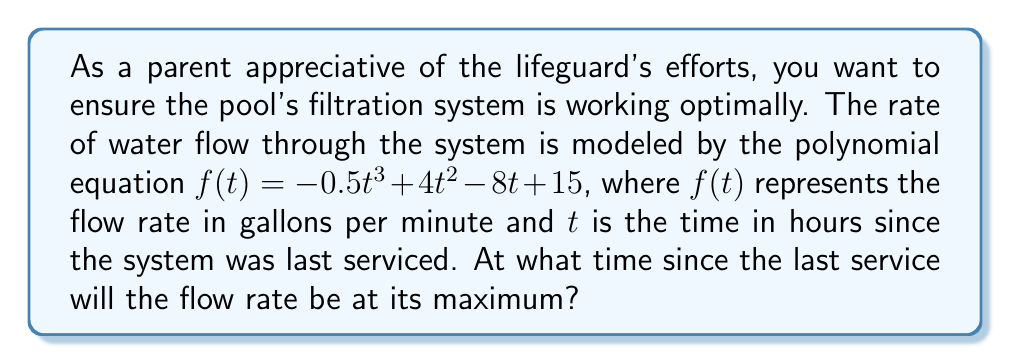Can you solve this math problem? To find the maximum flow rate, we need to determine the time $t$ when the derivative of $f(t)$ equals zero:

1) First, let's find the derivative of $f(t)$:
   $$f'(t) = -1.5t^2 + 8t - 8$$

2) Set $f'(t) = 0$ and solve for $t$:
   $$-1.5t^2 + 8t - 8 = 0$$

3) This is a quadratic equation. Let's solve it using the quadratic formula:
   $$t = \frac{-b \pm \sqrt{b^2 - 4ac}}{2a}$$
   where $a = -1.5$, $b = 8$, and $c = -8$

4) Substituting these values:
   $$t = \frac{-8 \pm \sqrt{8^2 - 4(-1.5)(-8)}}{2(-1.5)}$$
   $$= \frac{-8 \pm \sqrt{64 - 48}}{-3}$$
   $$= \frac{-8 \pm \sqrt{16}}{-3}$$
   $$= \frac{-8 \pm 4}{-3}$$

5) This gives us two solutions:
   $$t = \frac{-8 + 4}{-3} = \frac{-4}{-3} = \frac{4}{3}$$
   $$t = \frac{-8 - 4}{-3} = \frac{-12}{-3} = 4$$

6) To determine which of these is the maximum (rather than the minimum), we can check the second derivative:
   $$f''(t) = -3t + 8$$

7) Evaluating $f''(t)$ at $t = \frac{4}{3}$:
   $$f''(\frac{4}{3}) = -3(\frac{4}{3}) + 8 = -4 + 8 = 4 > 0$$

   This positive value indicates that $t = \frac{4}{3}$ is a local minimum.

8) Therefore, the maximum flow rate occurs at $t = 4$ hours after the last service.
Answer: 4 hours 